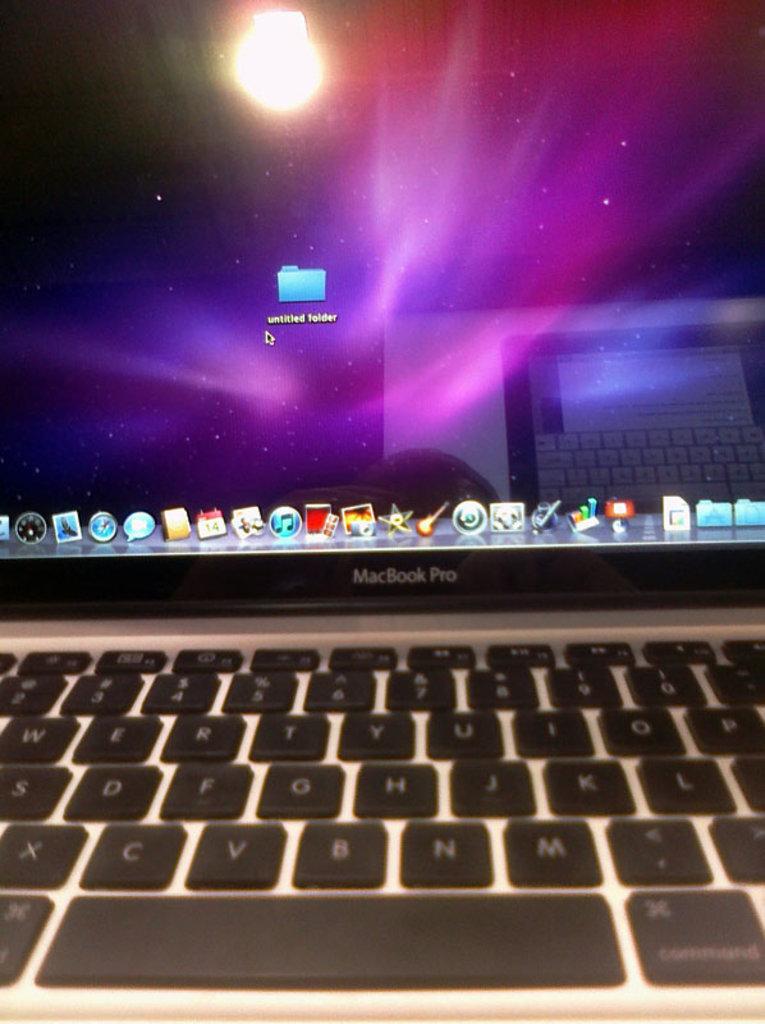Is that the sun shining off the screen?
Your answer should be compact. Answering does not require reading text in the image. What brand of laptop is this?
Give a very brief answer. Macbook pro. 